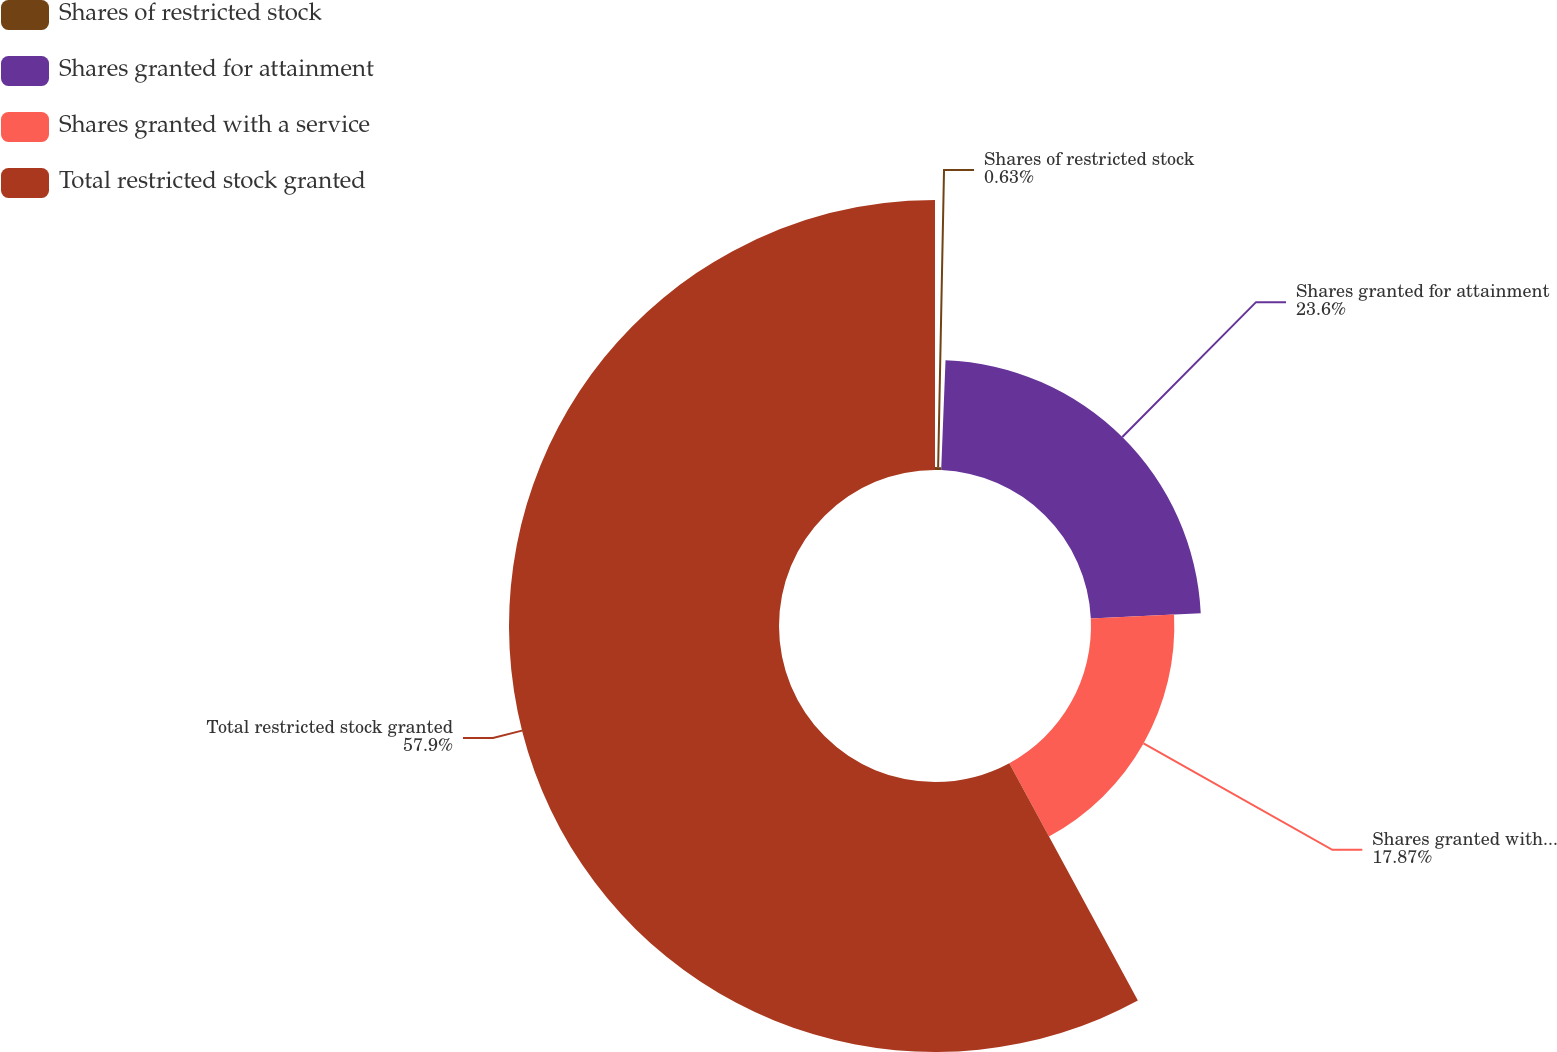Convert chart. <chart><loc_0><loc_0><loc_500><loc_500><pie_chart><fcel>Shares of restricted stock<fcel>Shares granted for attainment<fcel>Shares granted with a service<fcel>Total restricted stock granted<nl><fcel>0.63%<fcel>23.6%<fcel>17.87%<fcel>57.9%<nl></chart> 